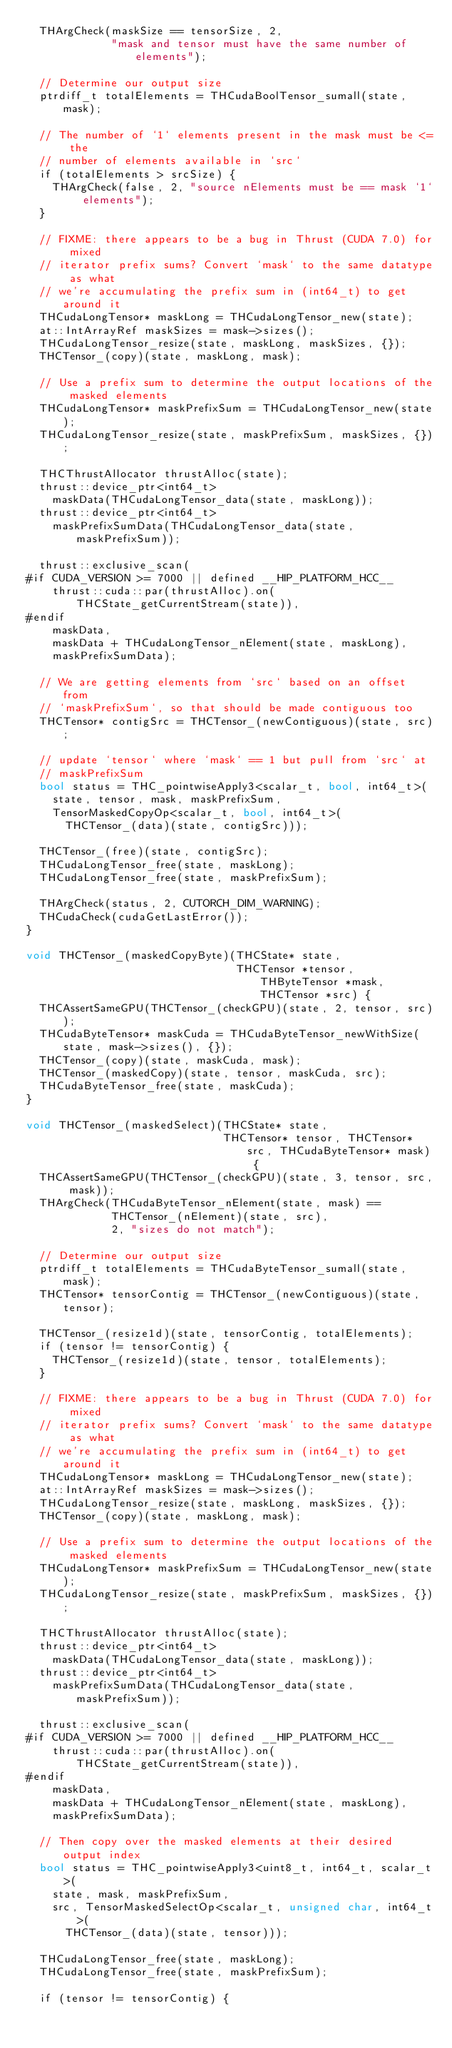Convert code to text. <code><loc_0><loc_0><loc_500><loc_500><_Cuda_>  THArgCheck(maskSize == tensorSize, 2,
             "mask and tensor must have the same number of elements");

  // Determine our output size
  ptrdiff_t totalElements = THCudaBoolTensor_sumall(state, mask);

  // The number of `1` elements present in the mask must be <= the
  // number of elements available in `src`
  if (totalElements > srcSize) {
    THArgCheck(false, 2, "source nElements must be == mask `1` elements");
  }

  // FIXME: there appears to be a bug in Thrust (CUDA 7.0) for mixed
  // iterator prefix sums? Convert `mask` to the same datatype as what
  // we're accumulating the prefix sum in (int64_t) to get around it
  THCudaLongTensor* maskLong = THCudaLongTensor_new(state);
  at::IntArrayRef maskSizes = mask->sizes();
  THCudaLongTensor_resize(state, maskLong, maskSizes, {});
  THCTensor_(copy)(state, maskLong, mask);

  // Use a prefix sum to determine the output locations of the masked elements
  THCudaLongTensor* maskPrefixSum = THCudaLongTensor_new(state);
  THCudaLongTensor_resize(state, maskPrefixSum, maskSizes, {});

  THCThrustAllocator thrustAlloc(state);
  thrust::device_ptr<int64_t>
    maskData(THCudaLongTensor_data(state, maskLong));
  thrust::device_ptr<int64_t>
    maskPrefixSumData(THCudaLongTensor_data(state, maskPrefixSum));

  thrust::exclusive_scan(
#if CUDA_VERSION >= 7000 || defined __HIP_PLATFORM_HCC__
    thrust::cuda::par(thrustAlloc).on(THCState_getCurrentStream(state)),
#endif
    maskData,
    maskData + THCudaLongTensor_nElement(state, maskLong),
    maskPrefixSumData);

  // We are getting elements from `src` based on an offset from
  // `maskPrefixSum`, so that should be made contiguous too
  THCTensor* contigSrc = THCTensor_(newContiguous)(state, src);

  // update `tensor` where `mask` == 1 but pull from `src` at
  // maskPrefixSum
  bool status = THC_pointwiseApply3<scalar_t, bool, int64_t>(
    state, tensor, mask, maskPrefixSum,
    TensorMaskedCopyOp<scalar_t, bool, int64_t>(
      THCTensor_(data)(state, contigSrc)));

  THCTensor_(free)(state, contigSrc);
  THCudaLongTensor_free(state, maskLong);
  THCudaLongTensor_free(state, maskPrefixSum);

  THArgCheck(status, 2, CUTORCH_DIM_WARNING);
  THCudaCheck(cudaGetLastError());
}

void THCTensor_(maskedCopyByte)(THCState* state,
                                THCTensor *tensor, THByteTensor *mask, THCTensor *src) {
  THCAssertSameGPU(THCTensor_(checkGPU)(state, 2, tensor, src));
  THCudaByteTensor* maskCuda = THCudaByteTensor_newWithSize(state, mask->sizes(), {});
  THCTensor_(copy)(state, maskCuda, mask);
  THCTensor_(maskedCopy)(state, tensor, maskCuda, src);
  THCudaByteTensor_free(state, maskCuda);
}

void THCTensor_(maskedSelect)(THCState* state,
                              THCTensor* tensor, THCTensor* src, THCudaByteTensor* mask) {
  THCAssertSameGPU(THCTensor_(checkGPU)(state, 3, tensor, src, mask));
  THArgCheck(THCudaByteTensor_nElement(state, mask) ==
             THCTensor_(nElement)(state, src),
             2, "sizes do not match");

  // Determine our output size
  ptrdiff_t totalElements = THCudaByteTensor_sumall(state, mask);
  THCTensor* tensorContig = THCTensor_(newContiguous)(state, tensor);

  THCTensor_(resize1d)(state, tensorContig, totalElements);
  if (tensor != tensorContig) {
    THCTensor_(resize1d)(state, tensor, totalElements);
  }

  // FIXME: there appears to be a bug in Thrust (CUDA 7.0) for mixed
  // iterator prefix sums? Convert `mask` to the same datatype as what
  // we're accumulating the prefix sum in (int64_t) to get around it
  THCudaLongTensor* maskLong = THCudaLongTensor_new(state);
  at::IntArrayRef maskSizes = mask->sizes();
  THCudaLongTensor_resize(state, maskLong, maskSizes, {});
  THCTensor_(copy)(state, maskLong, mask);

  // Use a prefix sum to determine the output locations of the masked elements
  THCudaLongTensor* maskPrefixSum = THCudaLongTensor_new(state);
  THCudaLongTensor_resize(state, maskPrefixSum, maskSizes, {});

  THCThrustAllocator thrustAlloc(state);
  thrust::device_ptr<int64_t>
    maskData(THCudaLongTensor_data(state, maskLong));
  thrust::device_ptr<int64_t>
    maskPrefixSumData(THCudaLongTensor_data(state, maskPrefixSum));

  thrust::exclusive_scan(
#if CUDA_VERSION >= 7000 || defined __HIP_PLATFORM_HCC__
    thrust::cuda::par(thrustAlloc).on(THCState_getCurrentStream(state)),
#endif
    maskData,
    maskData + THCudaLongTensor_nElement(state, maskLong),
    maskPrefixSumData);

  // Then copy over the masked elements at their desired output index
  bool status = THC_pointwiseApply3<uint8_t, int64_t, scalar_t>(
    state, mask, maskPrefixSum,
    src, TensorMaskedSelectOp<scalar_t, unsigned char, int64_t>(
      THCTensor_(data)(state, tensor)));

  THCudaLongTensor_free(state, maskLong);
  THCudaLongTensor_free(state, maskPrefixSum);

  if (tensor != tensorContig) {</code> 